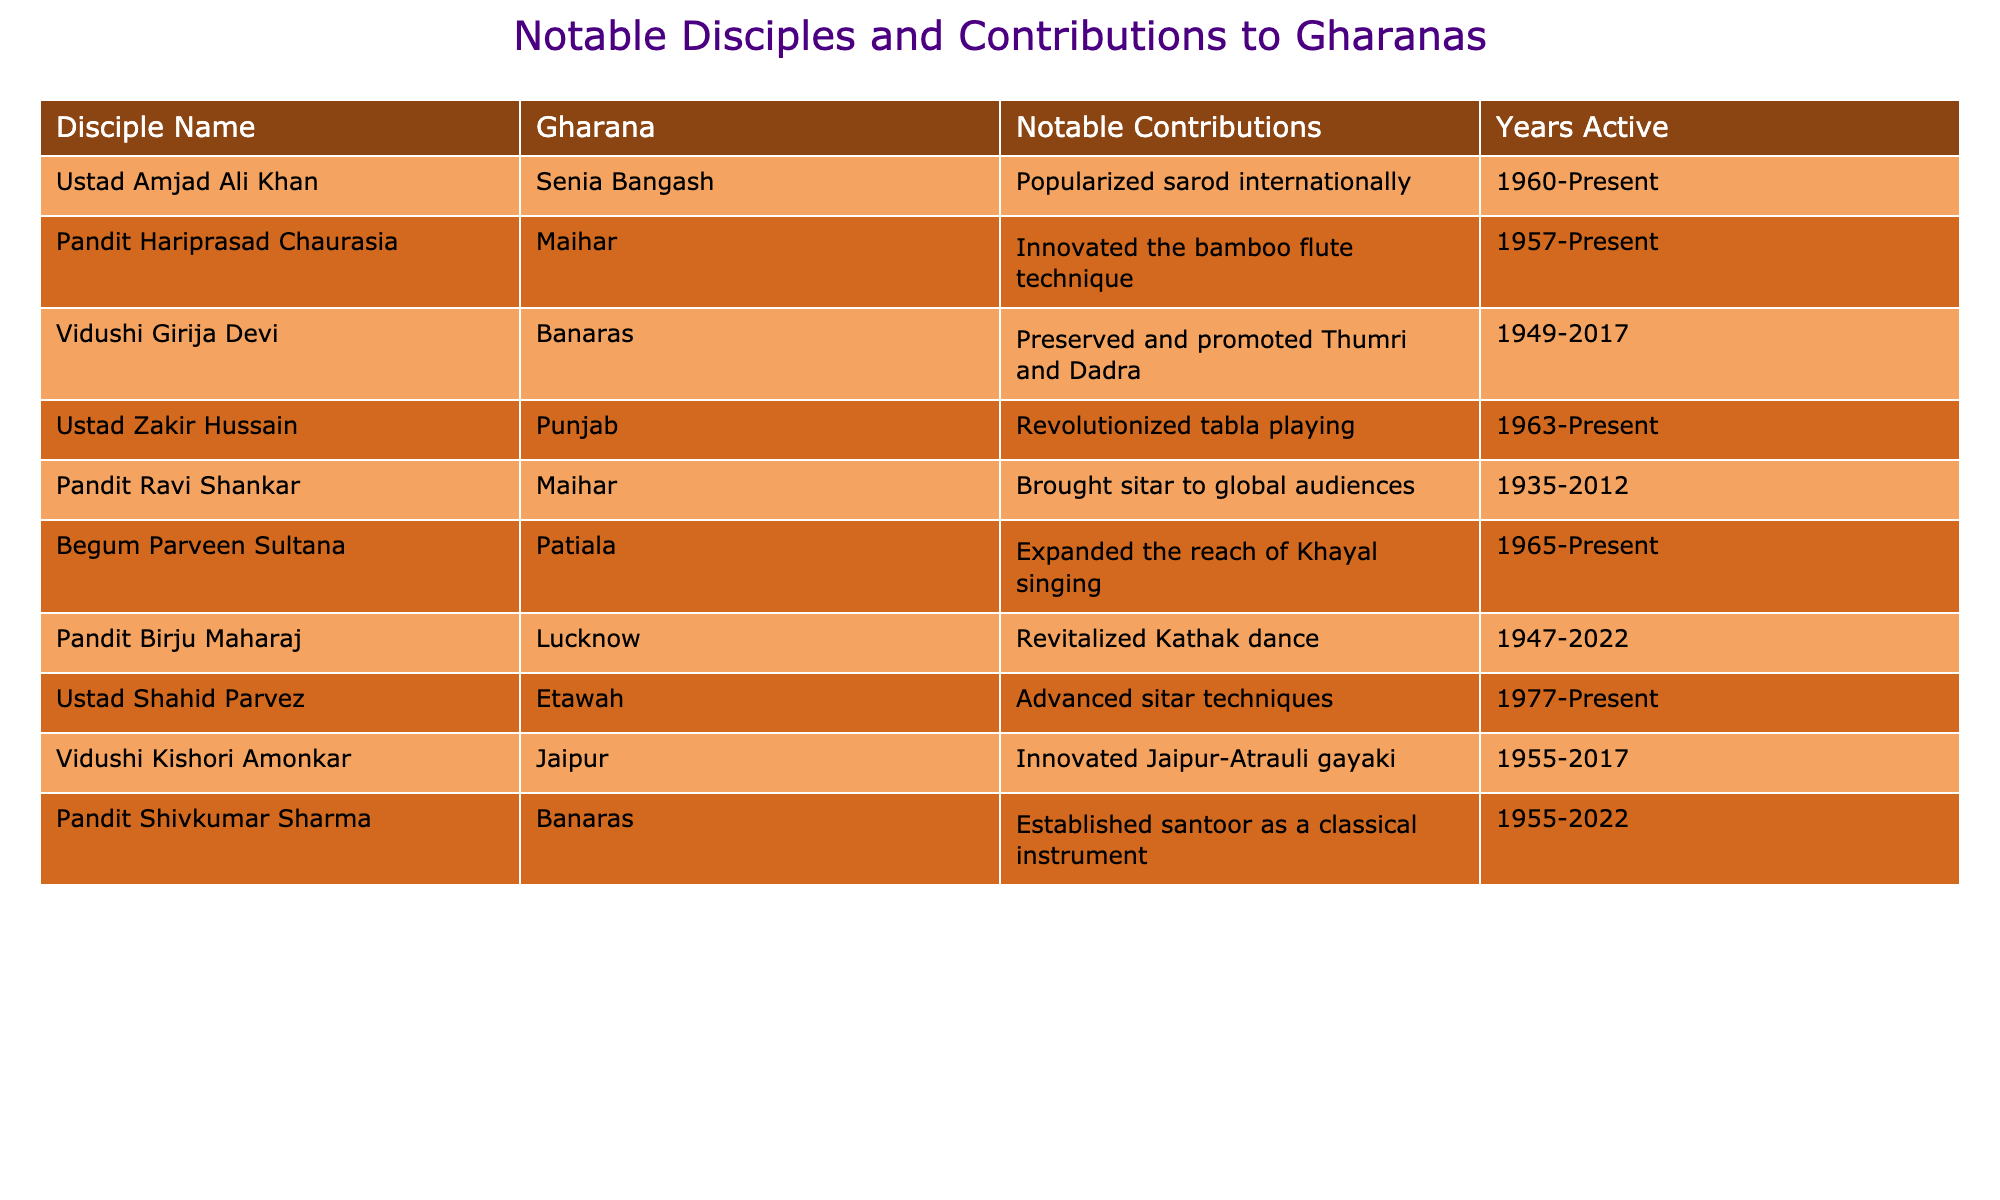What notable contribution did Ustad Amjad Ali Khan make? According to the table, Ustad Amjad Ali Khan popularized the sarod internationally.
Answer: He popularized the sarod internationally Which gharana is associated with Vidushi Girija Devi? The table shows that Vidushi Girija Devi is associated with the Banaras gharana.
Answer: Banaras How many disciples were active during the years 2000 to present? Analyzing the years active, the following disciples were active in this period: Ustad Amjad Ali Khan, Ustad Zakir Hussain, Begum Parveen Sultana, Ustad Shahid Parvez. That's a total of 4 disciples active during these years.
Answer: 4 Did Pandit Ravi Shankar contribute to the Maihar gharana? Yes, Pandit Ravi Shankar is listed under the Maihar gharana in the table.
Answer: Yes Who among the listed disciples was active the longest? The latest year of activity for any disciple is 2022 (Pandit Birju Maharaj and Pandit Shivkumar Sharma), while the earliest year of activity is 1935 (Pandit Ravi Shankar). Thus, the longest active period is from 1935 to 2022, totaling 87 years for Pandit Ravi Shankar.
Answer: Pandit Ravi Shankar How many disciples contributed to the Banaras gharana? The data shows two disciples associated with the Banaras gharana, which are Vidushi Girija Devi and Pandit Shivkumar Sharma.
Answer: 2 What is the notable contribution of Ustad Zakir Hussain? Ustad Zakir Hussain revolutionized tabla playing, as stated in the table.
Answer: He revolutionized tabla playing Which gharana has the most contribution listed in the table and who are they? The Maihar gharana has two notable contributions listed (Pandit Ravi Shankar and Pandit Hariprasad Chaurasia). Therefore, it is tied for the most contributions with the contributions from Banaras, which also has two.
Answer: Maihar and Banaras Is there any disciple who contributed to both music and dance? No, based on the table, all disciplines listed focus either on music or dance, and no individual is noted for contributions in both areas.
Answer: No 